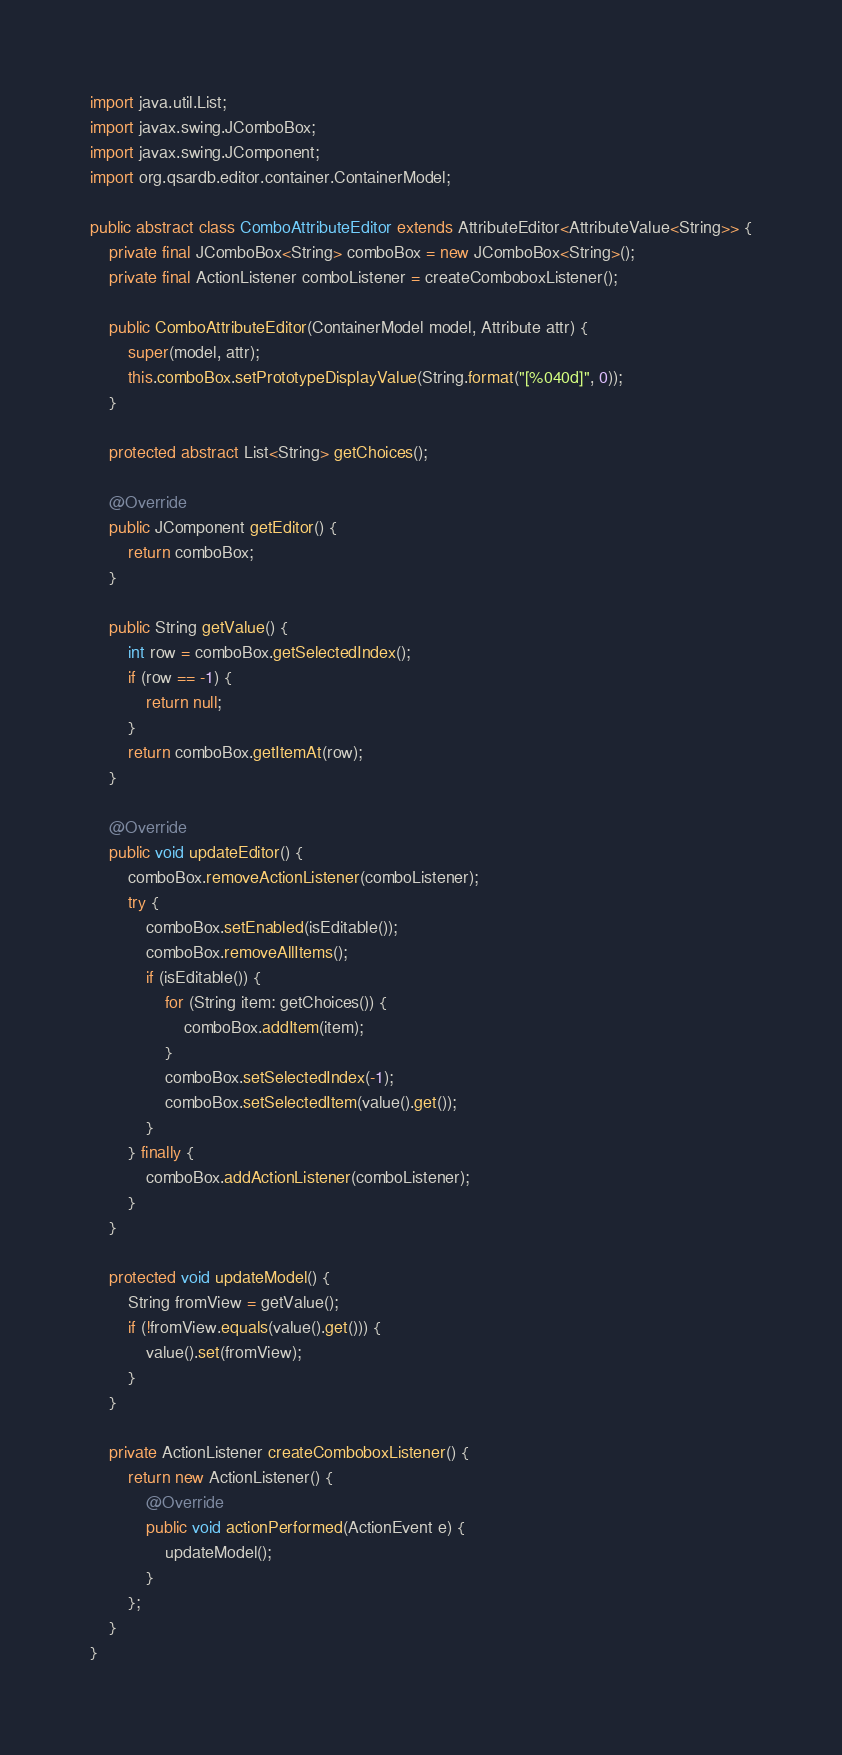Convert code to text. <code><loc_0><loc_0><loc_500><loc_500><_Java_>import java.util.List;
import javax.swing.JComboBox;
import javax.swing.JComponent;
import org.qsardb.editor.container.ContainerModel;

public abstract class ComboAttributeEditor extends AttributeEditor<AttributeValue<String>> {
	private final JComboBox<String> comboBox = new JComboBox<String>();
	private final ActionListener comboListener = createComboboxListener();

	public ComboAttributeEditor(ContainerModel model, Attribute attr) {
		super(model, attr);
		this.comboBox.setPrototypeDisplayValue(String.format("[%040d]", 0));
	}

	protected abstract List<String> getChoices();

	@Override
	public JComponent getEditor() {
		return comboBox;
	}

	public String getValue() {
		int row = comboBox.getSelectedIndex();
		if (row == -1) {
			return null;
		}
		return comboBox.getItemAt(row);
	}

	@Override
	public void updateEditor() {
		comboBox.removeActionListener(comboListener);
		try {
			comboBox.setEnabled(isEditable());
			comboBox.removeAllItems();
			if (isEditable()) {
				for (String item: getChoices()) {
					comboBox.addItem(item);
				}
				comboBox.setSelectedIndex(-1);
				comboBox.setSelectedItem(value().get());
			}
		} finally {
			comboBox.addActionListener(comboListener);
		}
	}

	protected void updateModel() {
		String fromView = getValue();
		if (!fromView.equals(value().get())) {
			value().set(fromView);
		}
	}

	private ActionListener createComboboxListener() {
		return new ActionListener() {
			@Override
			public void actionPerformed(ActionEvent e) {
				updateModel();
			}
		};
	}
}</code> 